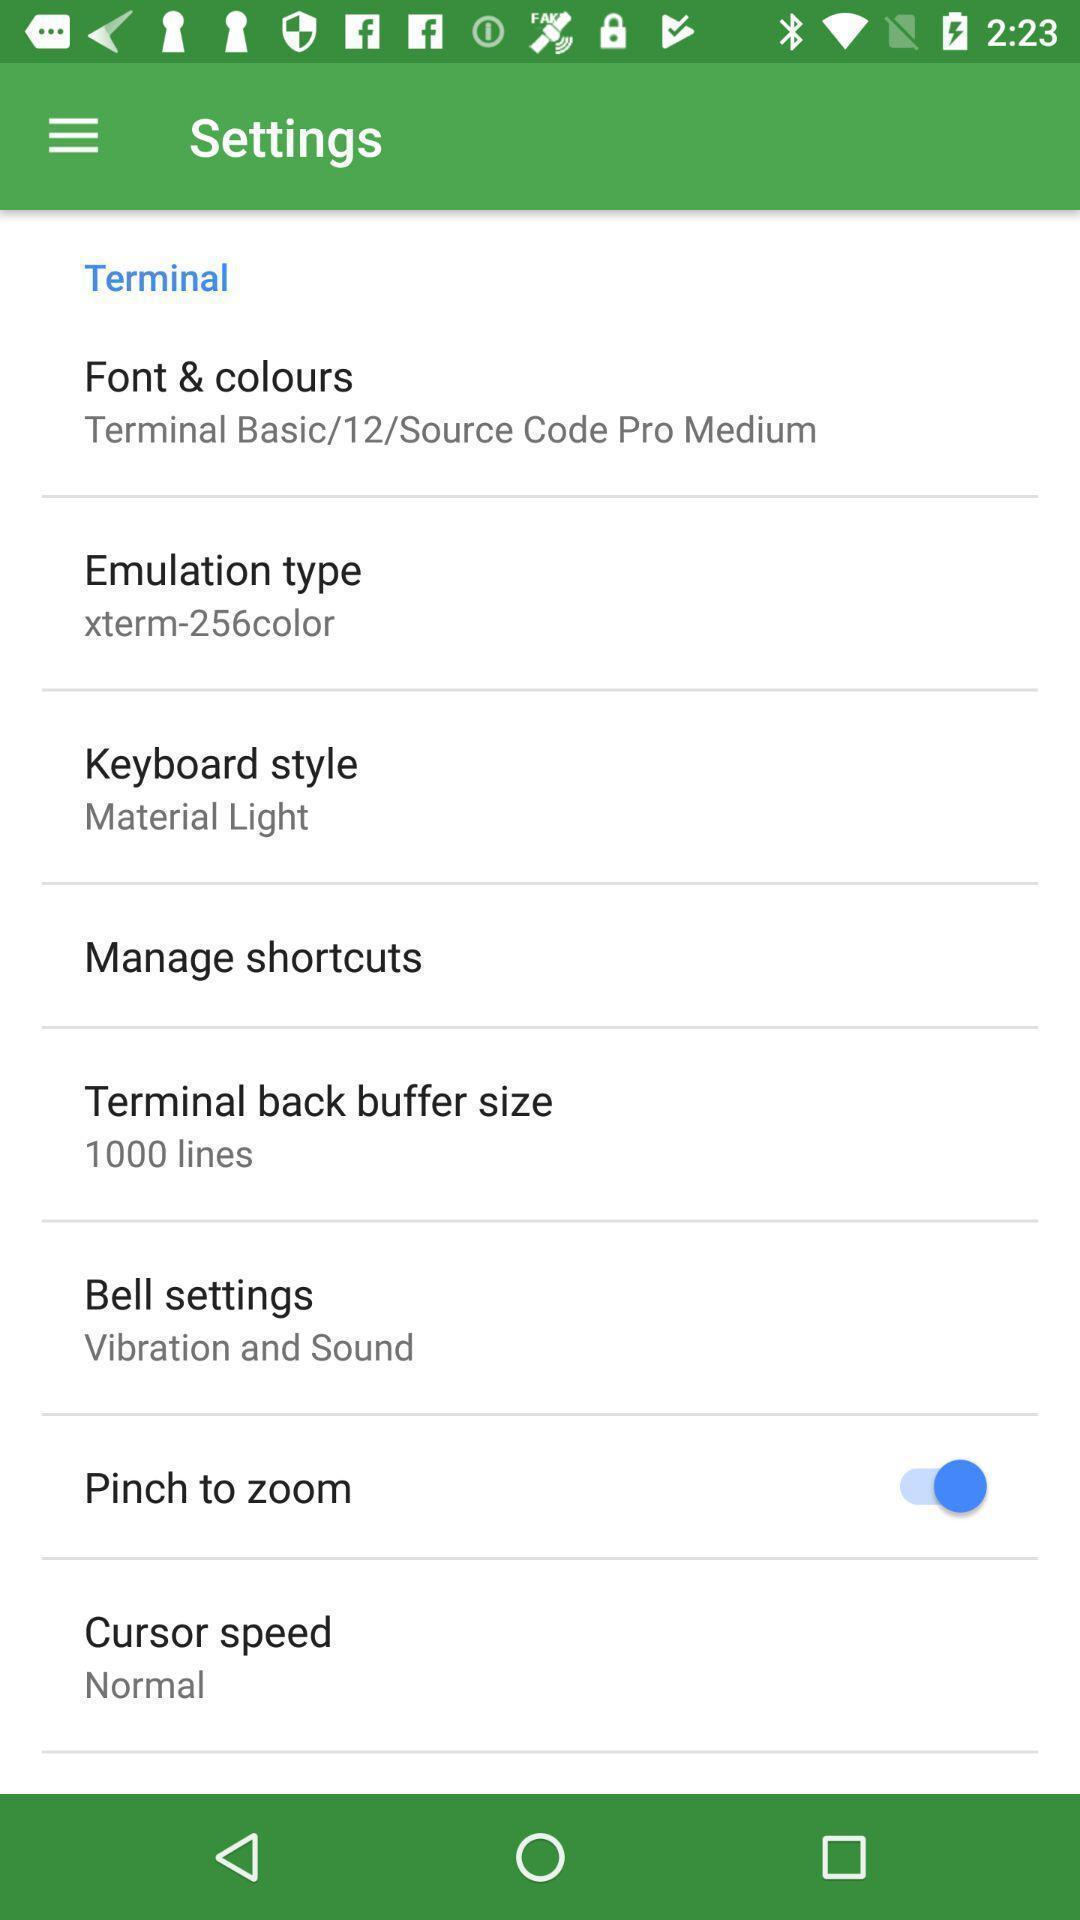Provide a description of this screenshot. Settings list showing in this page. 